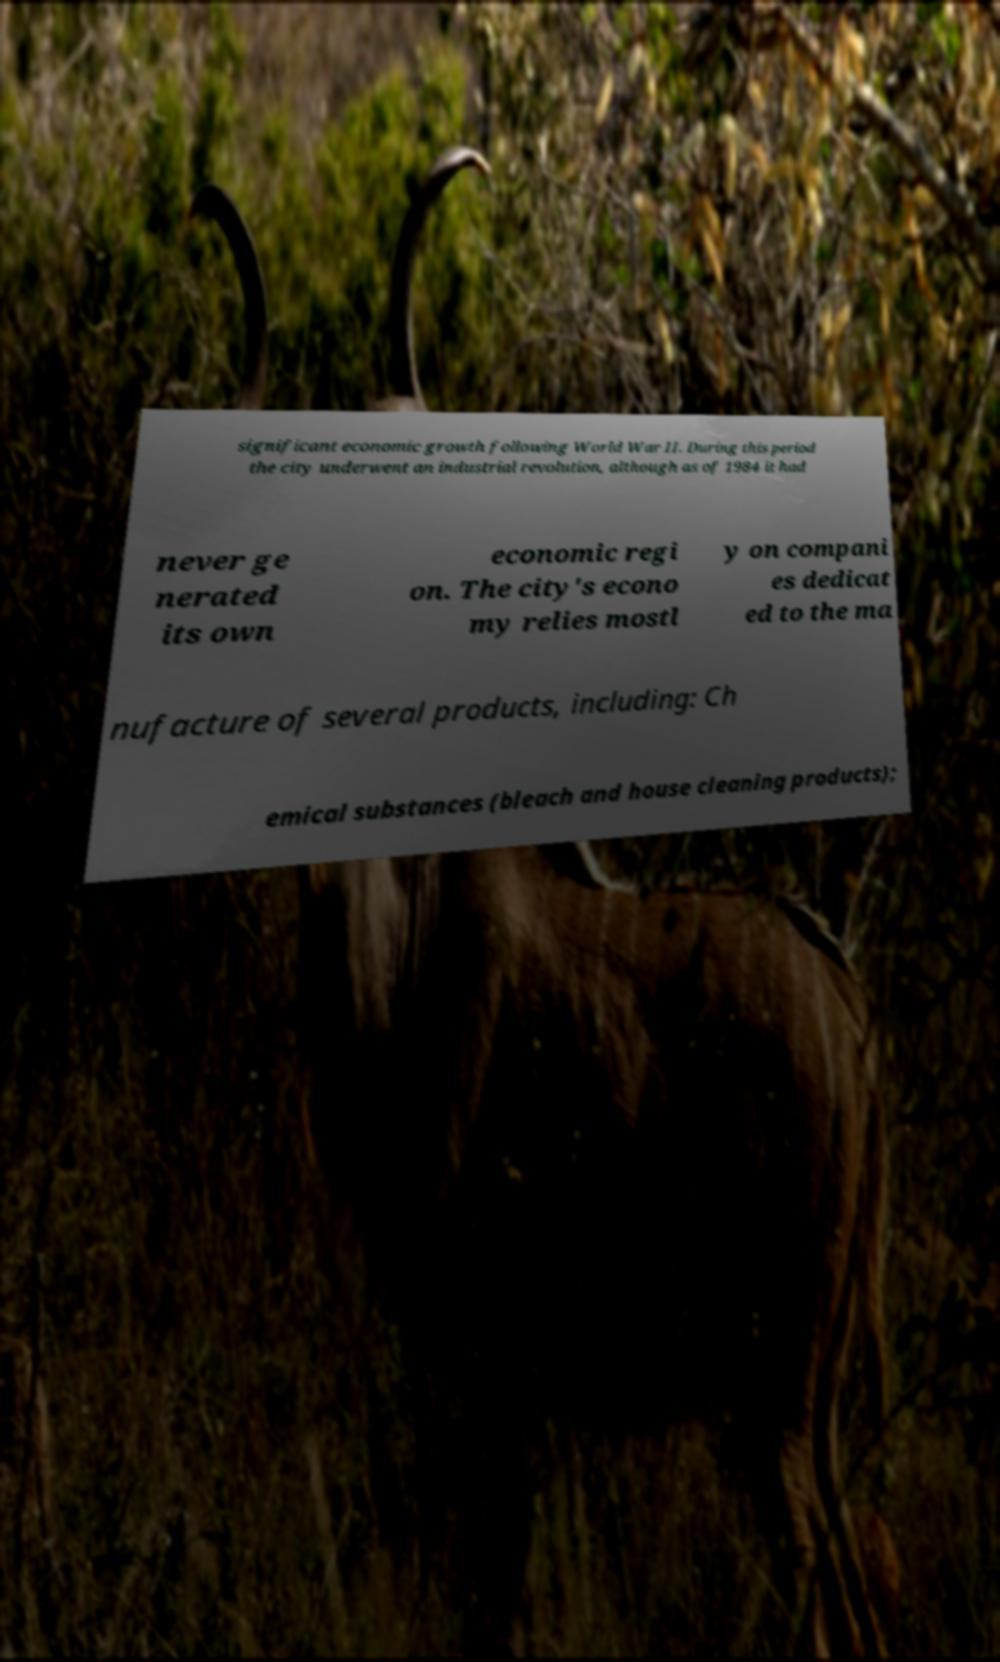For documentation purposes, I need the text within this image transcribed. Could you provide that? significant economic growth following World War II. During this period the city underwent an industrial revolution, although as of 1984 it had never ge nerated its own economic regi on. The city's econo my relies mostl y on compani es dedicat ed to the ma nufacture of several products, including: Ch emical substances (bleach and house cleaning products); 